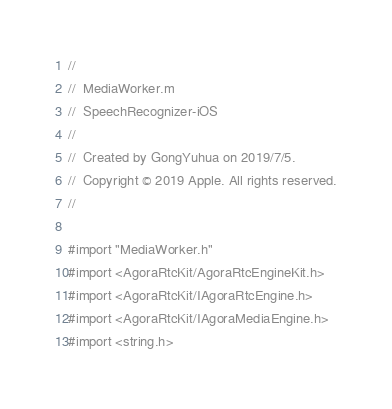Convert code to text. <code><loc_0><loc_0><loc_500><loc_500><_ObjectiveC_>//
//  MediaWorker.m
//  SpeechRecognizer-iOS
//
//  Created by GongYuhua on 2019/7/5.
//  Copyright © 2019 Apple. All rights reserved.
//

#import "MediaWorker.h"
#import <AgoraRtcKit/AgoraRtcEngineKit.h>
#import <AgoraRtcKit/IAgoraRtcEngine.h>
#import <AgoraRtcKit/IAgoraMediaEngine.h>
#import <string.h>
</code> 